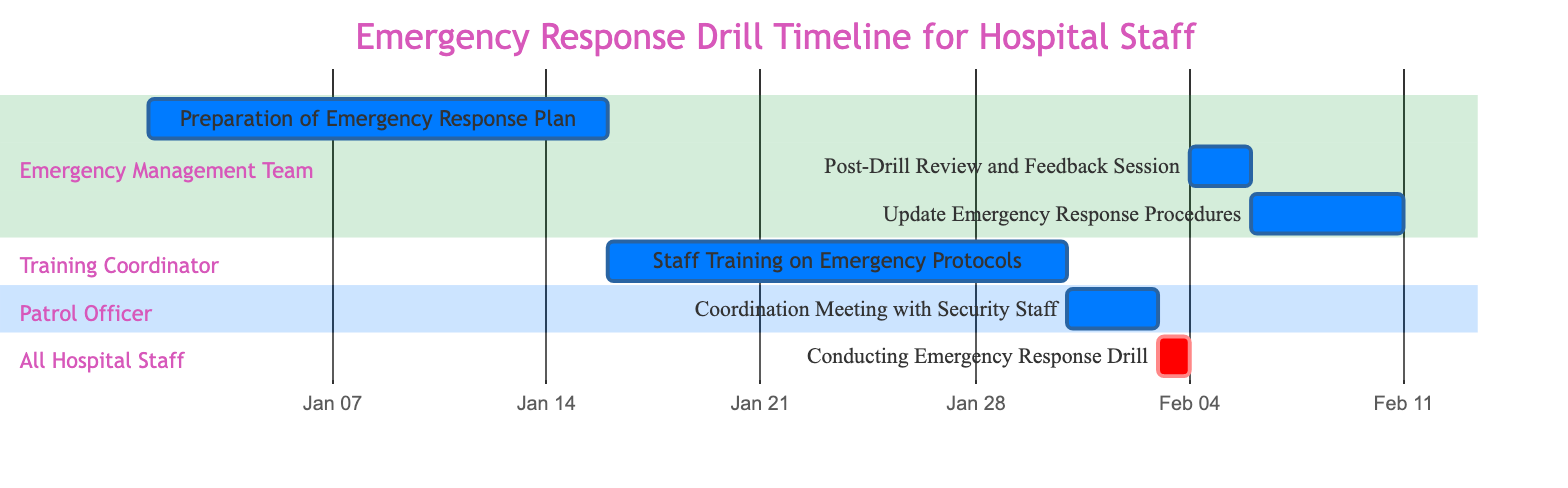What is the first task in the timeline? The first task listed in the Gantt chart is "Preparation of Emergency Response Plan," which is scheduled to start on January 1, 2024.
Answer: Preparation of Emergency Response Plan Who is responsible for the Staff Training on Emergency Protocols? The diagram indicates that the "Training Coordinator" is responsible for the task of "Staff Training on Emergency Protocols."
Answer: Training Coordinator How long is the Coordination Meeting with Security Staff scheduled for? The duration of the "Coordination Meeting with Security Staff" is mentioned to be 3 days, starting from January 31, 2024, to February 2, 2024.
Answer: 3 days What task occurs immediately after the Conducting Emergency Response Drill? Following the "Conducting Emergency Response Drill," the next task is "Post-Drill Review and Feedback Session," which begins February 4, 2024.
Answer: Post-Drill Review and Feedback Session How many total tasks are listed in the Gantt chart? The diagram displays a total of 6 tasks, including preparation, training, coordination, conducting the drill, review, and updates.
Answer: 6 tasks Which team is involved in updating the Emergency Response Procedures? The "Emergency Management Team" is responsible for the task of updating the Emergency Response Procedures, as indicated in the Gantt chart.
Answer: Emergency Management Team What is the duration of the task "Preparation of Emergency Response Plan"? The task "Preparation of Emergency Response Plan" lasts for 15 days, starting from January 1, 2024.
Answer: 15 days Which task is marked as critical in the diagram? The "Conducting Emergency Response Drill" task is marked as critical within the Gantt chart.
Answer: Conducting Emergency Response Drill What is the end date for the Update Emergency Response Procedures? The "Update Emergency Response Procedures" task is planned to end on February 10, 2024.
Answer: February 10, 2024 